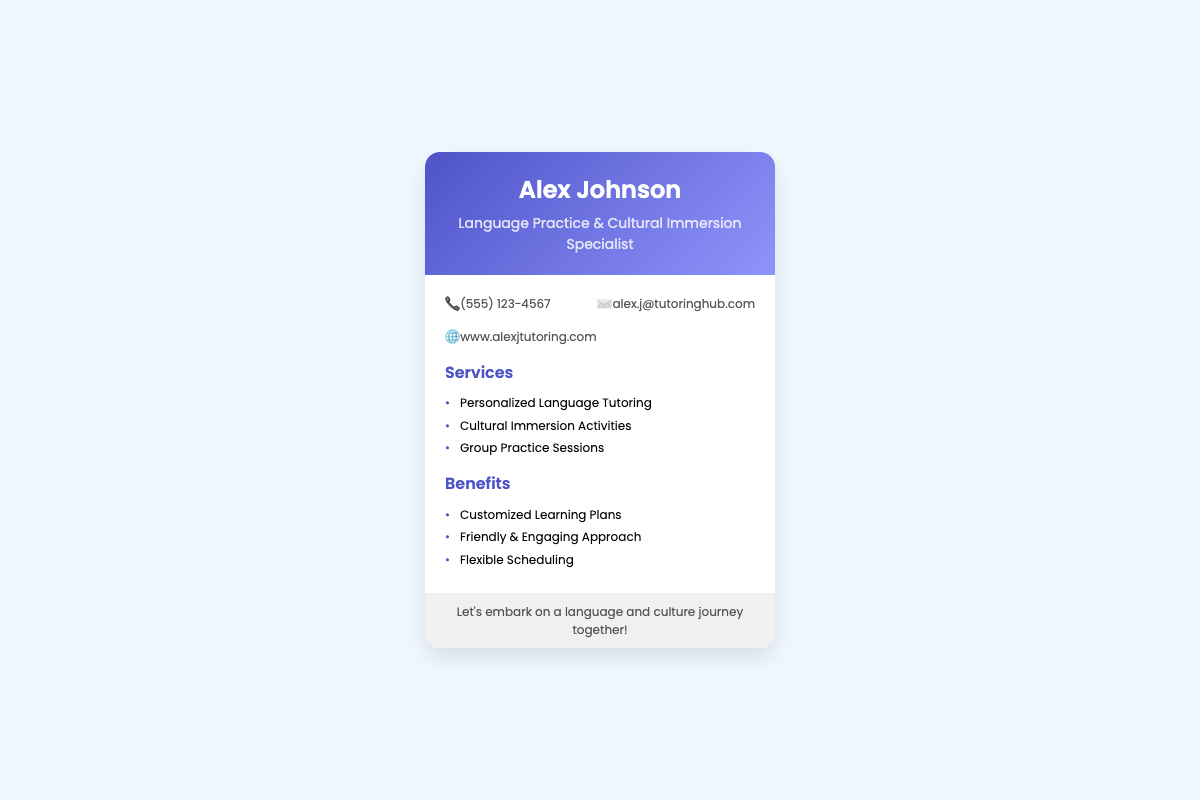What is the name of the specialist? The name of the specialist is prominently displayed in the header of the card.
Answer: Alex Johnson What kind of specialist is Alex? This indicates the area of expertise or service provided by Alex.
Answer: Language Practice & Cultural Immersion Specialist What is the phone number provided? The document includes the contact information where the phone number is stated.
Answer: (555) 123-4567 Which service involves group activities? This question looks for a specific tutoring service offered that entails multiple participants.
Answer: Group Practice Sessions What is one benefit of Alex's tutoring services? The benefits section lists several advantages related to the tutoring service.
Answer: Customized Learning Plans How many services are listed on the card? The total number of distinct services offered by Alex is included in the services section.
Answer: 3 What is the website for more information? The document contains the URL for Alex's tutoring services which can be accessed online.
Answer: www.alexjtutoring.com What type of activities are included in the services? This question seeks to understand the nature of the activities offered alongside tutoring.
Answer: Cultural Immersion Activities What is emphasized in the footer of the card? The footer conveys a welcoming message that encapsulates the main offering of the service.
Answer: Let's embark on a language and culture journey together! 